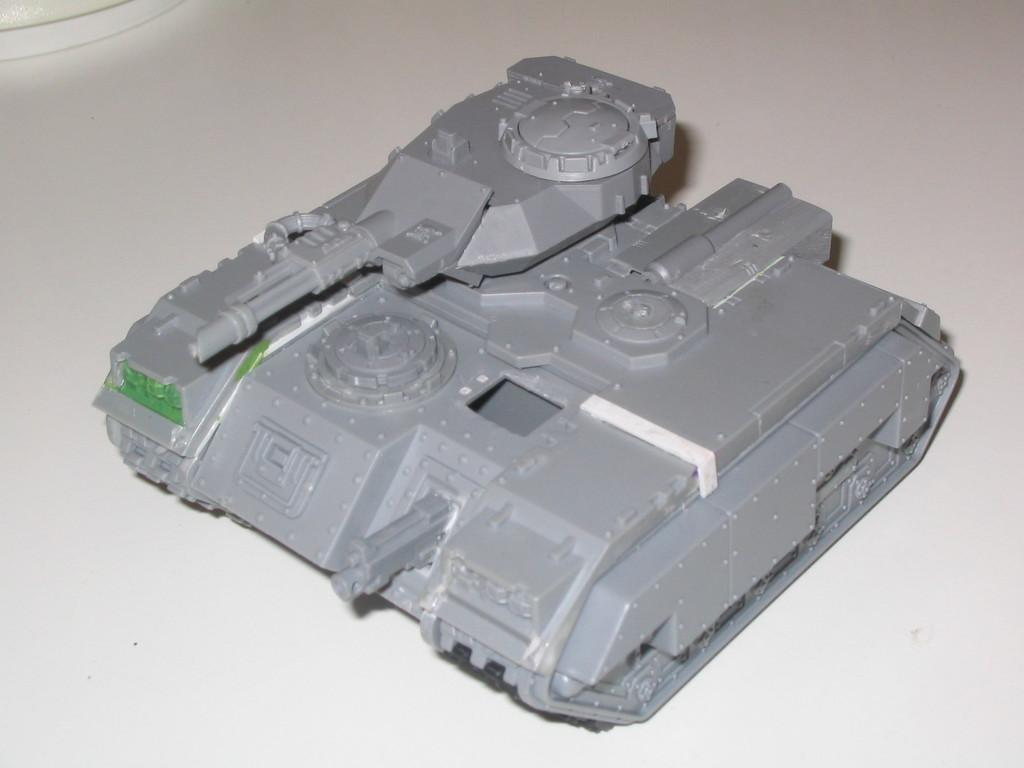What is the main subject of the image? The main subject of the image is a Churchill tank toy. What color is the tank toy? The tank toy is in grey color. What is the color of the background in the image? The background of the image is white in color. Can you see any birds comfortably perched on the tank toy in the image? There are no birds present in the image, and the tank toy is a toy, not a real tank, so it is not possible for birds to perch on it. 